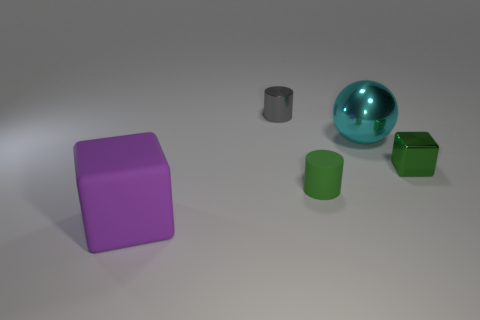What number of matte cubes have the same size as the green rubber cylinder?
Provide a short and direct response. 0. There is a green thing that is the same shape as the gray object; what is it made of?
Offer a terse response. Rubber. The tiny object that is on the left side of the sphere and in front of the big cyan shiny sphere has what shape?
Give a very brief answer. Cylinder. There is a large object to the right of the purple block; what shape is it?
Offer a terse response. Sphere. What number of things are both to the right of the gray cylinder and on the left side of the green metal object?
Your answer should be compact. 2. There is a cyan metal object; does it have the same size as the cylinder that is behind the small green metal object?
Provide a succinct answer. No. There is a shiny object that is on the left side of the cylinder that is right of the small object that is behind the ball; what is its size?
Keep it short and to the point. Small. There is a cylinder that is behind the small green metal object; what is its size?
Ensure brevity in your answer.  Small. What is the shape of the gray thing that is made of the same material as the cyan thing?
Give a very brief answer. Cylinder. Are the large thing that is behind the matte cube and the tiny gray cylinder made of the same material?
Ensure brevity in your answer.  Yes. 